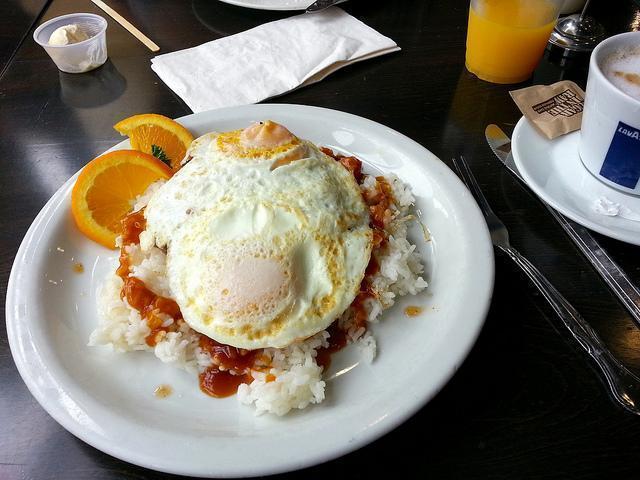What is in the tall glass on the right hand side?
Indicate the correct response by choosing from the four available options to answer the question.
Options: Root beer, orange juice, water, tomato juice. Orange juice. 